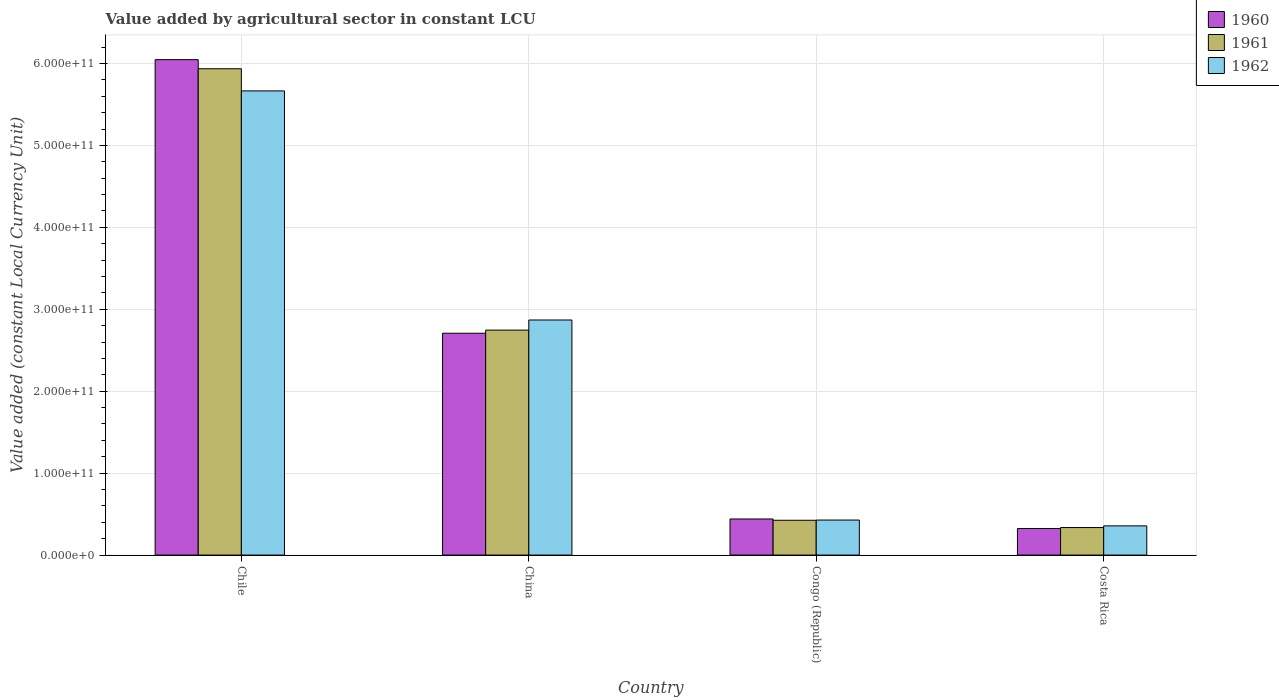Are the number of bars per tick equal to the number of legend labels?
Your response must be concise. Yes. What is the label of the 3rd group of bars from the left?
Your answer should be compact. Congo (Republic). In how many cases, is the number of bars for a given country not equal to the number of legend labels?
Ensure brevity in your answer.  0. What is the value added by agricultural sector in 1962 in Costa Rica?
Ensure brevity in your answer.  3.57e+1. Across all countries, what is the maximum value added by agricultural sector in 1962?
Keep it short and to the point. 5.67e+11. Across all countries, what is the minimum value added by agricultural sector in 1961?
Give a very brief answer. 3.36e+1. In which country was the value added by agricultural sector in 1960 minimum?
Your answer should be compact. Costa Rica. What is the total value added by agricultural sector in 1962 in the graph?
Your answer should be very brief. 9.32e+11. What is the difference between the value added by agricultural sector in 1962 in Congo (Republic) and that in Costa Rica?
Your answer should be compact. 7.08e+09. What is the difference between the value added by agricultural sector in 1961 in Congo (Republic) and the value added by agricultural sector in 1960 in Chile?
Your response must be concise. -5.62e+11. What is the average value added by agricultural sector in 1960 per country?
Make the answer very short. 2.38e+11. What is the difference between the value added by agricultural sector of/in 1961 and value added by agricultural sector of/in 1960 in Costa Rica?
Offer a very short reply. 1.19e+09. What is the ratio of the value added by agricultural sector in 1962 in Chile to that in China?
Provide a succinct answer. 1.97. What is the difference between the highest and the second highest value added by agricultural sector in 1962?
Your answer should be very brief. -2.80e+11. What is the difference between the highest and the lowest value added by agricultural sector in 1961?
Your response must be concise. 5.60e+11. In how many countries, is the value added by agricultural sector in 1962 greater than the average value added by agricultural sector in 1962 taken over all countries?
Keep it short and to the point. 2. What does the 3rd bar from the left in Costa Rica represents?
Keep it short and to the point. 1962. What does the 1st bar from the right in China represents?
Keep it short and to the point. 1962. Is it the case that in every country, the sum of the value added by agricultural sector in 1961 and value added by agricultural sector in 1960 is greater than the value added by agricultural sector in 1962?
Offer a terse response. Yes. How many bars are there?
Give a very brief answer. 12. Are all the bars in the graph horizontal?
Keep it short and to the point. No. What is the difference between two consecutive major ticks on the Y-axis?
Offer a terse response. 1.00e+11. Are the values on the major ticks of Y-axis written in scientific E-notation?
Ensure brevity in your answer.  Yes. Does the graph contain any zero values?
Offer a very short reply. No. Does the graph contain grids?
Provide a short and direct response. Yes. How many legend labels are there?
Your response must be concise. 3. What is the title of the graph?
Make the answer very short. Value added by agricultural sector in constant LCU. What is the label or title of the X-axis?
Your response must be concise. Country. What is the label or title of the Y-axis?
Provide a short and direct response. Value added (constant Local Currency Unit). What is the Value added (constant Local Currency Unit) in 1960 in Chile?
Your answer should be very brief. 6.05e+11. What is the Value added (constant Local Currency Unit) of 1961 in Chile?
Your answer should be very brief. 5.94e+11. What is the Value added (constant Local Currency Unit) in 1962 in Chile?
Provide a succinct answer. 5.67e+11. What is the Value added (constant Local Currency Unit) of 1960 in China?
Offer a terse response. 2.71e+11. What is the Value added (constant Local Currency Unit) of 1961 in China?
Your answer should be very brief. 2.75e+11. What is the Value added (constant Local Currency Unit) of 1962 in China?
Provide a succinct answer. 2.87e+11. What is the Value added (constant Local Currency Unit) in 1960 in Congo (Republic)?
Make the answer very short. 4.41e+1. What is the Value added (constant Local Currency Unit) of 1961 in Congo (Republic)?
Your answer should be very brief. 4.25e+1. What is the Value added (constant Local Currency Unit) in 1962 in Congo (Republic)?
Provide a short and direct response. 4.27e+1. What is the Value added (constant Local Currency Unit) of 1960 in Costa Rica?
Give a very brief answer. 3.24e+1. What is the Value added (constant Local Currency Unit) in 1961 in Costa Rica?
Your response must be concise. 3.36e+1. What is the Value added (constant Local Currency Unit) of 1962 in Costa Rica?
Make the answer very short. 3.57e+1. Across all countries, what is the maximum Value added (constant Local Currency Unit) of 1960?
Provide a short and direct response. 6.05e+11. Across all countries, what is the maximum Value added (constant Local Currency Unit) in 1961?
Keep it short and to the point. 5.94e+11. Across all countries, what is the maximum Value added (constant Local Currency Unit) of 1962?
Provide a succinct answer. 5.67e+11. Across all countries, what is the minimum Value added (constant Local Currency Unit) in 1960?
Offer a very short reply. 3.24e+1. Across all countries, what is the minimum Value added (constant Local Currency Unit) of 1961?
Ensure brevity in your answer.  3.36e+1. Across all countries, what is the minimum Value added (constant Local Currency Unit) in 1962?
Provide a succinct answer. 3.57e+1. What is the total Value added (constant Local Currency Unit) in 1960 in the graph?
Give a very brief answer. 9.52e+11. What is the total Value added (constant Local Currency Unit) of 1961 in the graph?
Your answer should be very brief. 9.44e+11. What is the total Value added (constant Local Currency Unit) in 1962 in the graph?
Keep it short and to the point. 9.32e+11. What is the difference between the Value added (constant Local Currency Unit) in 1960 in Chile and that in China?
Keep it short and to the point. 3.34e+11. What is the difference between the Value added (constant Local Currency Unit) in 1961 in Chile and that in China?
Make the answer very short. 3.19e+11. What is the difference between the Value added (constant Local Currency Unit) in 1962 in Chile and that in China?
Ensure brevity in your answer.  2.80e+11. What is the difference between the Value added (constant Local Currency Unit) in 1960 in Chile and that in Congo (Republic)?
Your answer should be very brief. 5.61e+11. What is the difference between the Value added (constant Local Currency Unit) in 1961 in Chile and that in Congo (Republic)?
Provide a short and direct response. 5.51e+11. What is the difference between the Value added (constant Local Currency Unit) in 1962 in Chile and that in Congo (Republic)?
Offer a terse response. 5.24e+11. What is the difference between the Value added (constant Local Currency Unit) of 1960 in Chile and that in Costa Rica?
Offer a terse response. 5.72e+11. What is the difference between the Value added (constant Local Currency Unit) in 1961 in Chile and that in Costa Rica?
Your answer should be compact. 5.60e+11. What is the difference between the Value added (constant Local Currency Unit) in 1962 in Chile and that in Costa Rica?
Offer a terse response. 5.31e+11. What is the difference between the Value added (constant Local Currency Unit) in 1960 in China and that in Congo (Republic)?
Your answer should be very brief. 2.27e+11. What is the difference between the Value added (constant Local Currency Unit) of 1961 in China and that in Congo (Republic)?
Make the answer very short. 2.32e+11. What is the difference between the Value added (constant Local Currency Unit) of 1962 in China and that in Congo (Republic)?
Provide a succinct answer. 2.44e+11. What is the difference between the Value added (constant Local Currency Unit) in 1960 in China and that in Costa Rica?
Make the answer very short. 2.38e+11. What is the difference between the Value added (constant Local Currency Unit) of 1961 in China and that in Costa Rica?
Your answer should be compact. 2.41e+11. What is the difference between the Value added (constant Local Currency Unit) in 1962 in China and that in Costa Rica?
Your response must be concise. 2.51e+11. What is the difference between the Value added (constant Local Currency Unit) of 1960 in Congo (Republic) and that in Costa Rica?
Make the answer very short. 1.17e+1. What is the difference between the Value added (constant Local Currency Unit) in 1961 in Congo (Republic) and that in Costa Rica?
Your response must be concise. 8.89e+09. What is the difference between the Value added (constant Local Currency Unit) of 1962 in Congo (Republic) and that in Costa Rica?
Provide a succinct answer. 7.08e+09. What is the difference between the Value added (constant Local Currency Unit) of 1960 in Chile and the Value added (constant Local Currency Unit) of 1961 in China?
Your answer should be compact. 3.30e+11. What is the difference between the Value added (constant Local Currency Unit) of 1960 in Chile and the Value added (constant Local Currency Unit) of 1962 in China?
Your answer should be very brief. 3.18e+11. What is the difference between the Value added (constant Local Currency Unit) of 1961 in Chile and the Value added (constant Local Currency Unit) of 1962 in China?
Make the answer very short. 3.07e+11. What is the difference between the Value added (constant Local Currency Unit) in 1960 in Chile and the Value added (constant Local Currency Unit) in 1961 in Congo (Republic)?
Give a very brief answer. 5.62e+11. What is the difference between the Value added (constant Local Currency Unit) in 1960 in Chile and the Value added (constant Local Currency Unit) in 1962 in Congo (Republic)?
Offer a terse response. 5.62e+11. What is the difference between the Value added (constant Local Currency Unit) of 1961 in Chile and the Value added (constant Local Currency Unit) of 1962 in Congo (Republic)?
Your response must be concise. 5.51e+11. What is the difference between the Value added (constant Local Currency Unit) of 1960 in Chile and the Value added (constant Local Currency Unit) of 1961 in Costa Rica?
Your answer should be compact. 5.71e+11. What is the difference between the Value added (constant Local Currency Unit) of 1960 in Chile and the Value added (constant Local Currency Unit) of 1962 in Costa Rica?
Your response must be concise. 5.69e+11. What is the difference between the Value added (constant Local Currency Unit) of 1961 in Chile and the Value added (constant Local Currency Unit) of 1962 in Costa Rica?
Your response must be concise. 5.58e+11. What is the difference between the Value added (constant Local Currency Unit) in 1960 in China and the Value added (constant Local Currency Unit) in 1961 in Congo (Republic)?
Your answer should be very brief. 2.28e+11. What is the difference between the Value added (constant Local Currency Unit) of 1960 in China and the Value added (constant Local Currency Unit) of 1962 in Congo (Republic)?
Offer a terse response. 2.28e+11. What is the difference between the Value added (constant Local Currency Unit) of 1961 in China and the Value added (constant Local Currency Unit) of 1962 in Congo (Republic)?
Your response must be concise. 2.32e+11. What is the difference between the Value added (constant Local Currency Unit) of 1960 in China and the Value added (constant Local Currency Unit) of 1961 in Costa Rica?
Ensure brevity in your answer.  2.37e+11. What is the difference between the Value added (constant Local Currency Unit) in 1960 in China and the Value added (constant Local Currency Unit) in 1962 in Costa Rica?
Keep it short and to the point. 2.35e+11. What is the difference between the Value added (constant Local Currency Unit) of 1961 in China and the Value added (constant Local Currency Unit) of 1962 in Costa Rica?
Give a very brief answer. 2.39e+11. What is the difference between the Value added (constant Local Currency Unit) of 1960 in Congo (Republic) and the Value added (constant Local Currency Unit) of 1961 in Costa Rica?
Give a very brief answer. 1.05e+1. What is the difference between the Value added (constant Local Currency Unit) of 1960 in Congo (Republic) and the Value added (constant Local Currency Unit) of 1962 in Costa Rica?
Provide a succinct answer. 8.40e+09. What is the difference between the Value added (constant Local Currency Unit) of 1961 in Congo (Republic) and the Value added (constant Local Currency Unit) of 1962 in Costa Rica?
Provide a short and direct response. 6.83e+09. What is the average Value added (constant Local Currency Unit) of 1960 per country?
Offer a very short reply. 2.38e+11. What is the average Value added (constant Local Currency Unit) in 1961 per country?
Offer a very short reply. 2.36e+11. What is the average Value added (constant Local Currency Unit) in 1962 per country?
Your response must be concise. 2.33e+11. What is the difference between the Value added (constant Local Currency Unit) of 1960 and Value added (constant Local Currency Unit) of 1961 in Chile?
Keep it short and to the point. 1.11e+1. What is the difference between the Value added (constant Local Currency Unit) in 1960 and Value added (constant Local Currency Unit) in 1962 in Chile?
Offer a very short reply. 3.82e+1. What is the difference between the Value added (constant Local Currency Unit) in 1961 and Value added (constant Local Currency Unit) in 1962 in Chile?
Your answer should be compact. 2.70e+1. What is the difference between the Value added (constant Local Currency Unit) in 1960 and Value added (constant Local Currency Unit) in 1961 in China?
Your answer should be compact. -3.79e+09. What is the difference between the Value added (constant Local Currency Unit) of 1960 and Value added (constant Local Currency Unit) of 1962 in China?
Ensure brevity in your answer.  -1.61e+1. What is the difference between the Value added (constant Local Currency Unit) in 1961 and Value added (constant Local Currency Unit) in 1962 in China?
Provide a succinct answer. -1.24e+1. What is the difference between the Value added (constant Local Currency Unit) of 1960 and Value added (constant Local Currency Unit) of 1961 in Congo (Republic)?
Provide a succinct answer. 1.57e+09. What is the difference between the Value added (constant Local Currency Unit) in 1960 and Value added (constant Local Currency Unit) in 1962 in Congo (Republic)?
Your answer should be very brief. 1.32e+09. What is the difference between the Value added (constant Local Currency Unit) of 1961 and Value added (constant Local Currency Unit) of 1962 in Congo (Republic)?
Provide a short and direct response. -2.56e+08. What is the difference between the Value added (constant Local Currency Unit) of 1960 and Value added (constant Local Currency Unit) of 1961 in Costa Rica?
Give a very brief answer. -1.19e+09. What is the difference between the Value added (constant Local Currency Unit) in 1960 and Value added (constant Local Currency Unit) in 1962 in Costa Rica?
Offer a very short reply. -3.25e+09. What is the difference between the Value added (constant Local Currency Unit) in 1961 and Value added (constant Local Currency Unit) in 1962 in Costa Rica?
Give a very brief answer. -2.06e+09. What is the ratio of the Value added (constant Local Currency Unit) in 1960 in Chile to that in China?
Offer a terse response. 2.23. What is the ratio of the Value added (constant Local Currency Unit) in 1961 in Chile to that in China?
Give a very brief answer. 2.16. What is the ratio of the Value added (constant Local Currency Unit) in 1962 in Chile to that in China?
Provide a succinct answer. 1.97. What is the ratio of the Value added (constant Local Currency Unit) of 1960 in Chile to that in Congo (Republic)?
Ensure brevity in your answer.  13.73. What is the ratio of the Value added (constant Local Currency Unit) in 1961 in Chile to that in Congo (Republic)?
Ensure brevity in your answer.  13.97. What is the ratio of the Value added (constant Local Currency Unit) in 1962 in Chile to that in Congo (Republic)?
Make the answer very short. 13.26. What is the ratio of the Value added (constant Local Currency Unit) in 1960 in Chile to that in Costa Rica?
Offer a terse response. 18.66. What is the ratio of the Value added (constant Local Currency Unit) of 1961 in Chile to that in Costa Rica?
Keep it short and to the point. 17.67. What is the ratio of the Value added (constant Local Currency Unit) of 1962 in Chile to that in Costa Rica?
Provide a short and direct response. 15.89. What is the ratio of the Value added (constant Local Currency Unit) in 1960 in China to that in Congo (Republic)?
Keep it short and to the point. 6.15. What is the ratio of the Value added (constant Local Currency Unit) in 1961 in China to that in Congo (Republic)?
Provide a succinct answer. 6.46. What is the ratio of the Value added (constant Local Currency Unit) in 1962 in China to that in Congo (Republic)?
Your answer should be compact. 6.71. What is the ratio of the Value added (constant Local Currency Unit) of 1960 in China to that in Costa Rica?
Offer a very short reply. 8.36. What is the ratio of the Value added (constant Local Currency Unit) in 1961 in China to that in Costa Rica?
Your answer should be very brief. 8.17. What is the ratio of the Value added (constant Local Currency Unit) of 1962 in China to that in Costa Rica?
Provide a short and direct response. 8.05. What is the ratio of the Value added (constant Local Currency Unit) of 1960 in Congo (Republic) to that in Costa Rica?
Offer a terse response. 1.36. What is the ratio of the Value added (constant Local Currency Unit) of 1961 in Congo (Republic) to that in Costa Rica?
Your response must be concise. 1.26. What is the ratio of the Value added (constant Local Currency Unit) of 1962 in Congo (Republic) to that in Costa Rica?
Your answer should be very brief. 1.2. What is the difference between the highest and the second highest Value added (constant Local Currency Unit) in 1960?
Make the answer very short. 3.34e+11. What is the difference between the highest and the second highest Value added (constant Local Currency Unit) in 1961?
Give a very brief answer. 3.19e+11. What is the difference between the highest and the second highest Value added (constant Local Currency Unit) of 1962?
Provide a short and direct response. 2.80e+11. What is the difference between the highest and the lowest Value added (constant Local Currency Unit) in 1960?
Offer a very short reply. 5.72e+11. What is the difference between the highest and the lowest Value added (constant Local Currency Unit) in 1961?
Your answer should be very brief. 5.60e+11. What is the difference between the highest and the lowest Value added (constant Local Currency Unit) in 1962?
Your answer should be compact. 5.31e+11. 